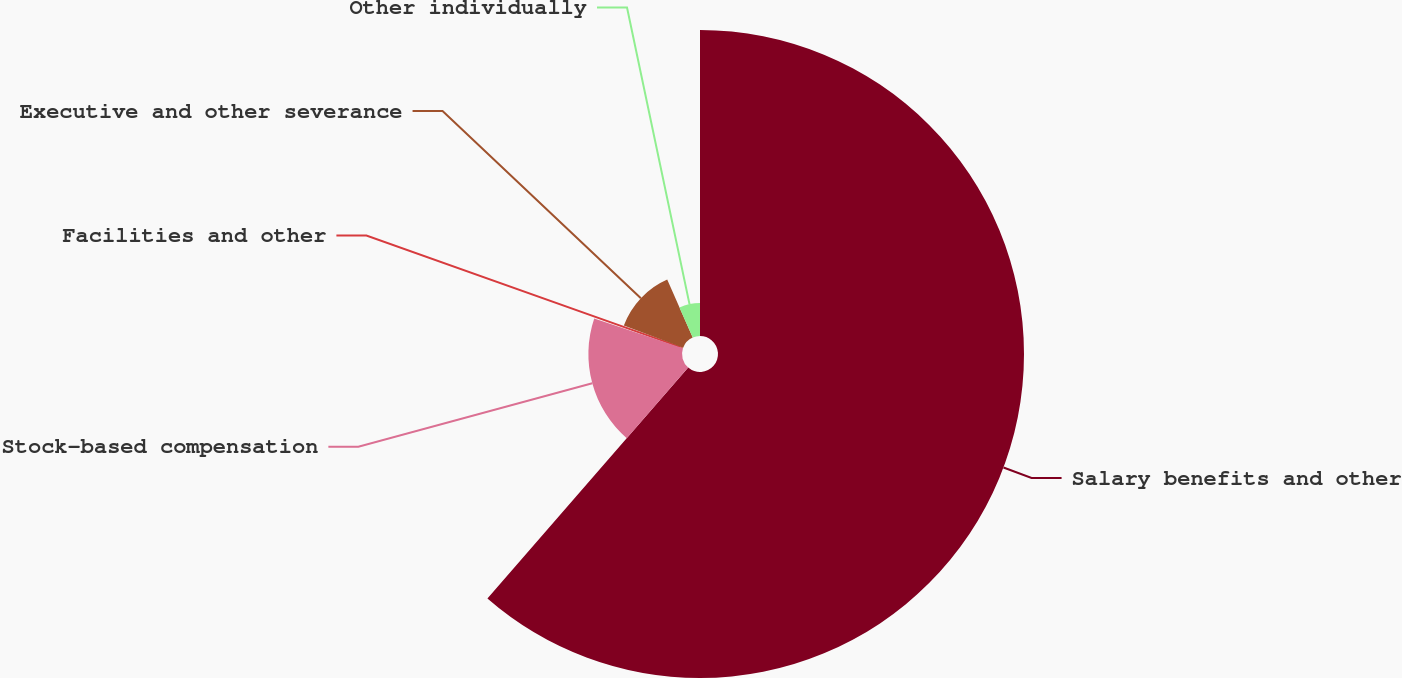Convert chart to OTSL. <chart><loc_0><loc_0><loc_500><loc_500><pie_chart><fcel>Salary benefits and other<fcel>Stock-based compensation<fcel>Facilities and other<fcel>Executive and other severance<fcel>Other individually<nl><fcel>61.39%<fcel>18.78%<fcel>0.52%<fcel>12.7%<fcel>6.61%<nl></chart> 